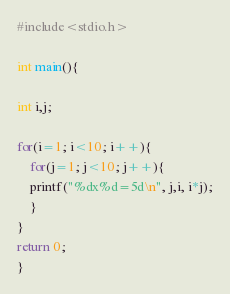Convert code to text. <code><loc_0><loc_0><loc_500><loc_500><_C_>#include<stdio.h>

int main(){

int i,j;

for(i=1; i<10; i++){
	for(j=1; j<10; j++){
	printf("%dx%d=5d\n", j,i, i*j);
	}
}
return 0;
}</code> 